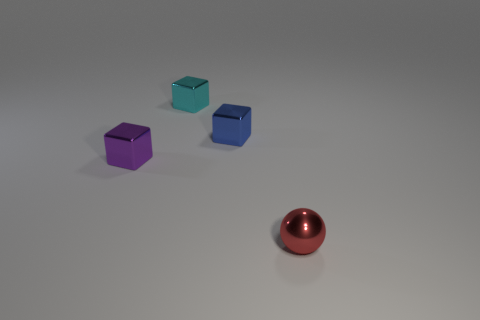Subtract all cyan metal cubes. How many cubes are left? 2 Add 1 tiny brown metallic cylinders. How many objects exist? 5 Subtract all cyan blocks. How many blocks are left? 2 Subtract 2 cubes. How many cubes are left? 1 Subtract all purple cubes. How many brown balls are left? 0 Subtract all large cyan shiny things. Subtract all tiny blue metallic blocks. How many objects are left? 3 Add 3 cyan objects. How many cyan objects are left? 4 Add 1 red spheres. How many red spheres exist? 2 Subtract 1 cyan blocks. How many objects are left? 3 Subtract all spheres. How many objects are left? 3 